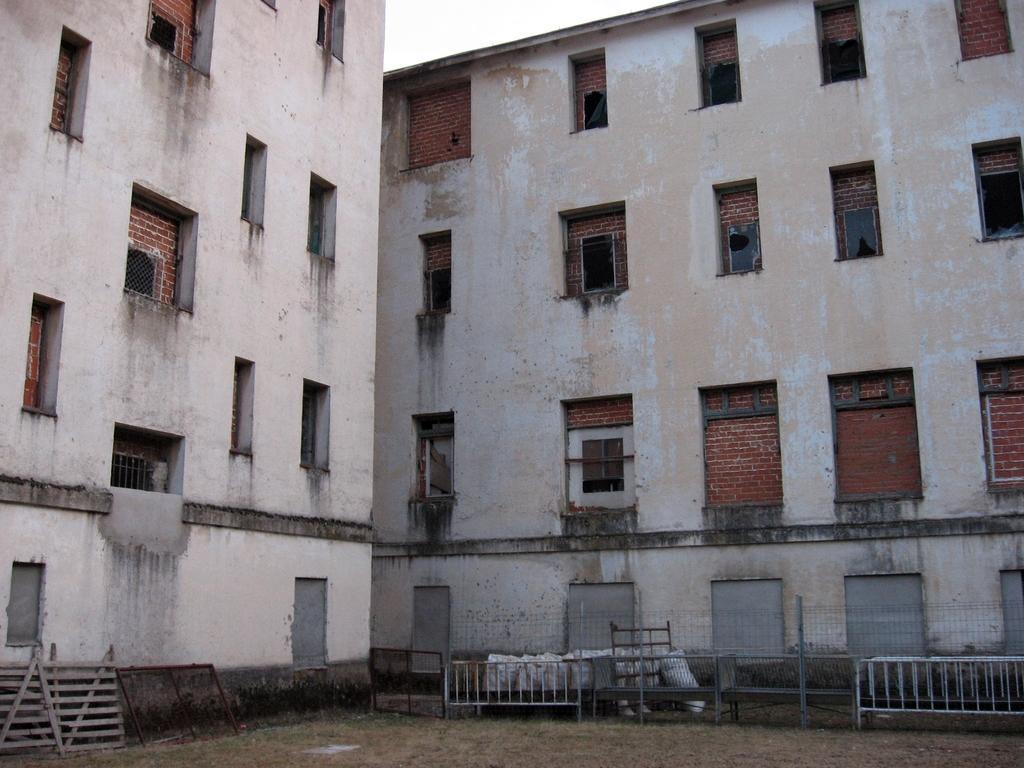How would you summarize this image in a sentence or two? In this image, I can see two buildings with the windows. At the bottom of the image, there are wooden fence, iron gates, barricades and few other objects. 